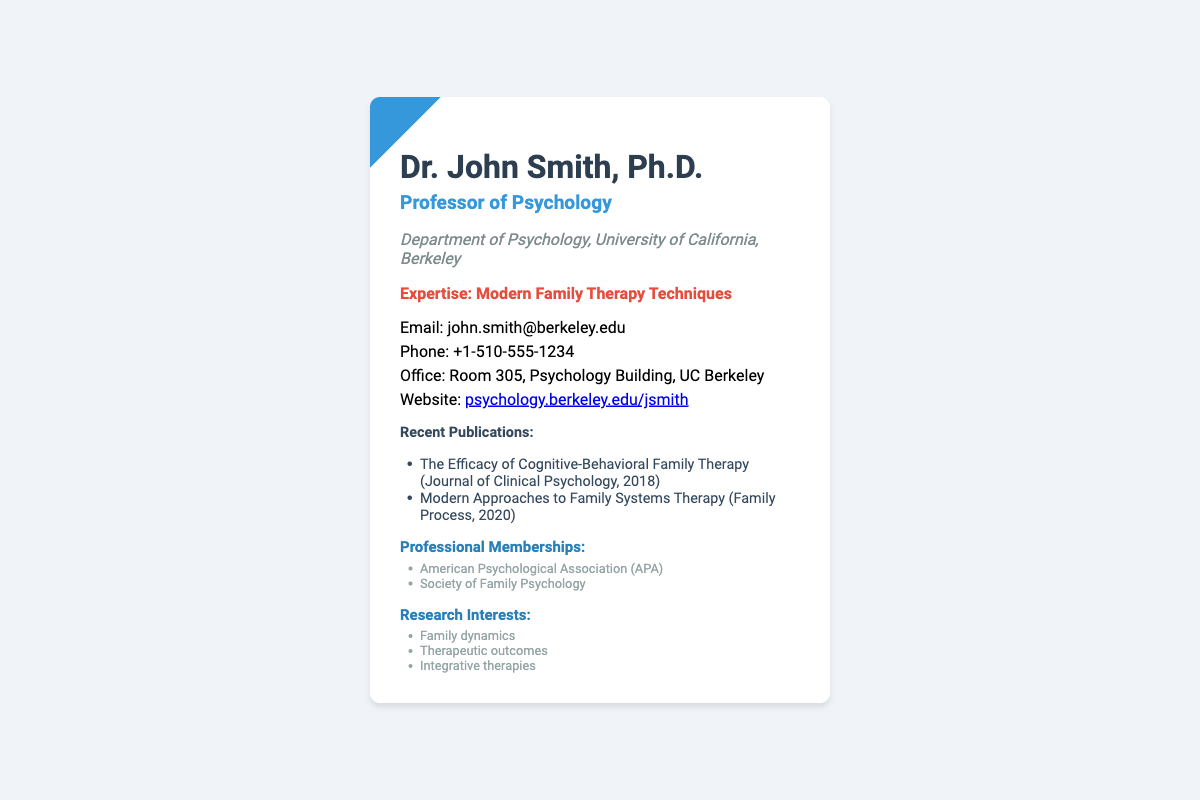What is the name of the professor? The name of the professor is presented prominently at the top of the card as "Dr. John Smith, Ph.D."
Answer: Dr. John Smith, Ph.D What is the professor's email address? The email address is provided in the contact information section of the card as john.smith@berkeley.edu.
Answer: john.smith@berkeley.edu What is the office location of Dr. John Smith? The office location is indicated in the contact information as "Room 305, Psychology Building, UC Berkeley."
Answer: Room 305, Psychology Building, UC Berkeley Which department is Dr. John Smith affiliated with? The affiliation is stated clearly on the card in the line "Department of Psychology, University of California, Berkeley."
Answer: Department of Psychology, University of California, Berkeley What are the recent publications listed? The card lists two recent publications: "The Efficacy of Cognitive-Behavioral Family Therapy" and "Modern Approaches to Family Systems Therapy."
Answer: The Efficacy of Cognitive-Behavioral Family Therapy; Modern Approaches to Family Systems Therapy How many professional memberships does Dr. Smith have listed? The card lists two memberships: "American Psychological Association (APA)" and "Society of Family Psychology."
Answer: Two What expertise does Dr. Smith claim? The expertise mentioned on the card is "Modern Family Therapy Techniques."
Answer: Modern Family Therapy Techniques What is Dr. Smith’s main research interest area? The main area of research interest is indicated with specific interests such as "Family dynamics," "Therapeutic outcomes," and "Integrative therapies."
Answer: Family dynamics; Therapeutic outcomes; Integrative therapies How is the card visually designed? The card features a modern design with a blue accent and rounded corners, emphasizing a clean and professional aesthetic.
Answer: Modern design with blue accent and rounded corners 